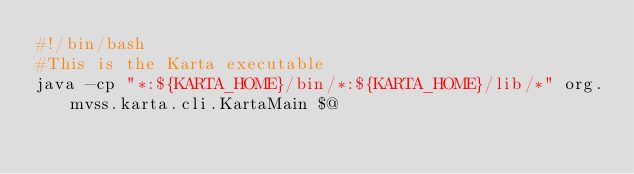Convert code to text. <code><loc_0><loc_0><loc_500><loc_500><_Bash_>#!/bin/bash
#This is the Karta executable
java -cp "*:${KARTA_HOME}/bin/*:${KARTA_HOME}/lib/*" org.mvss.karta.cli.KartaMain $@</code> 